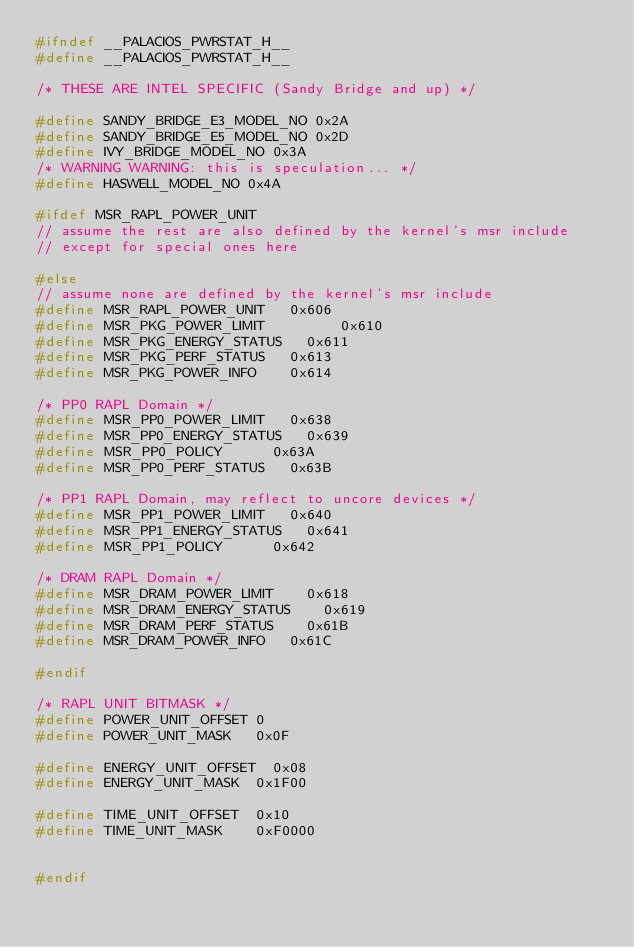<code> <loc_0><loc_0><loc_500><loc_500><_C_>#ifndef __PALACIOS_PWRSTAT_H__
#define __PALACIOS_PWRSTAT_H__

/* THESE ARE INTEL SPECIFIC (Sandy Bridge and up) */

#define SANDY_BRIDGE_E3_MODEL_NO 0x2A
#define SANDY_BRIDGE_E5_MODEL_NO 0x2D
#define IVY_BRIDGE_MODEL_NO 0x3A
/* WARNING WARNING: this is speculation... */
#define HASWELL_MODEL_NO 0x4A

#ifdef MSR_RAPL_POWER_UNIT
// assume the rest are also defined by the kernel's msr include
// except for special ones here

#else
// assume none are defined by the kernel's msr include
#define MSR_RAPL_POWER_UNIT		0x606
#define MSR_PKG_POWER_LIMIT	        0x610
#define MSR_PKG_ENERGY_STATUS		0x611
#define MSR_PKG_PERF_STATUS		0x613
#define MSR_PKG_POWER_INFO		0x614

/* PP0 RAPL Domain */
#define MSR_PP0_POWER_LIMIT		0x638
#define MSR_PP0_ENERGY_STATUS		0x639
#define MSR_PP0_POLICY			0x63A
#define MSR_PP0_PERF_STATUS		0x63B

/* PP1 RAPL Domain, may reflect to uncore devices */
#define MSR_PP1_POWER_LIMIT		0x640
#define MSR_PP1_ENERGY_STATUS		0x641
#define MSR_PP1_POLICY			0x642

/* DRAM RAPL Domain */
#define MSR_DRAM_POWER_LIMIT		0x618
#define MSR_DRAM_ENERGY_STATUS		0x619
#define MSR_DRAM_PERF_STATUS		0x61B
#define MSR_DRAM_POWER_INFO		0x61C

#endif

/* RAPL UNIT BITMASK */
#define POWER_UNIT_OFFSET	0
#define POWER_UNIT_MASK		0x0F

#define ENERGY_UNIT_OFFSET	0x08
#define ENERGY_UNIT_MASK	0x1F00

#define TIME_UNIT_OFFSET	0x10
#define TIME_UNIT_MASK		0xF0000


#endif
</code> 